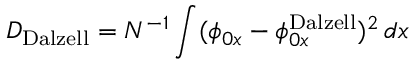<formula> <loc_0><loc_0><loc_500><loc_500>D _ { D a l z e l l } = N ^ { - 1 } \int ( \phi _ { 0 x } - \phi _ { 0 x } ^ { D a l z e l l } ) ^ { 2 } \, d x</formula> 